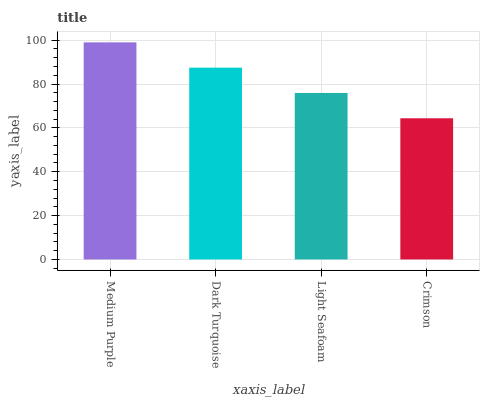Is Dark Turquoise the minimum?
Answer yes or no. No. Is Dark Turquoise the maximum?
Answer yes or no. No. Is Medium Purple greater than Dark Turquoise?
Answer yes or no. Yes. Is Dark Turquoise less than Medium Purple?
Answer yes or no. Yes. Is Dark Turquoise greater than Medium Purple?
Answer yes or no. No. Is Medium Purple less than Dark Turquoise?
Answer yes or no. No. Is Dark Turquoise the high median?
Answer yes or no. Yes. Is Light Seafoam the low median?
Answer yes or no. Yes. Is Medium Purple the high median?
Answer yes or no. No. Is Crimson the low median?
Answer yes or no. No. 